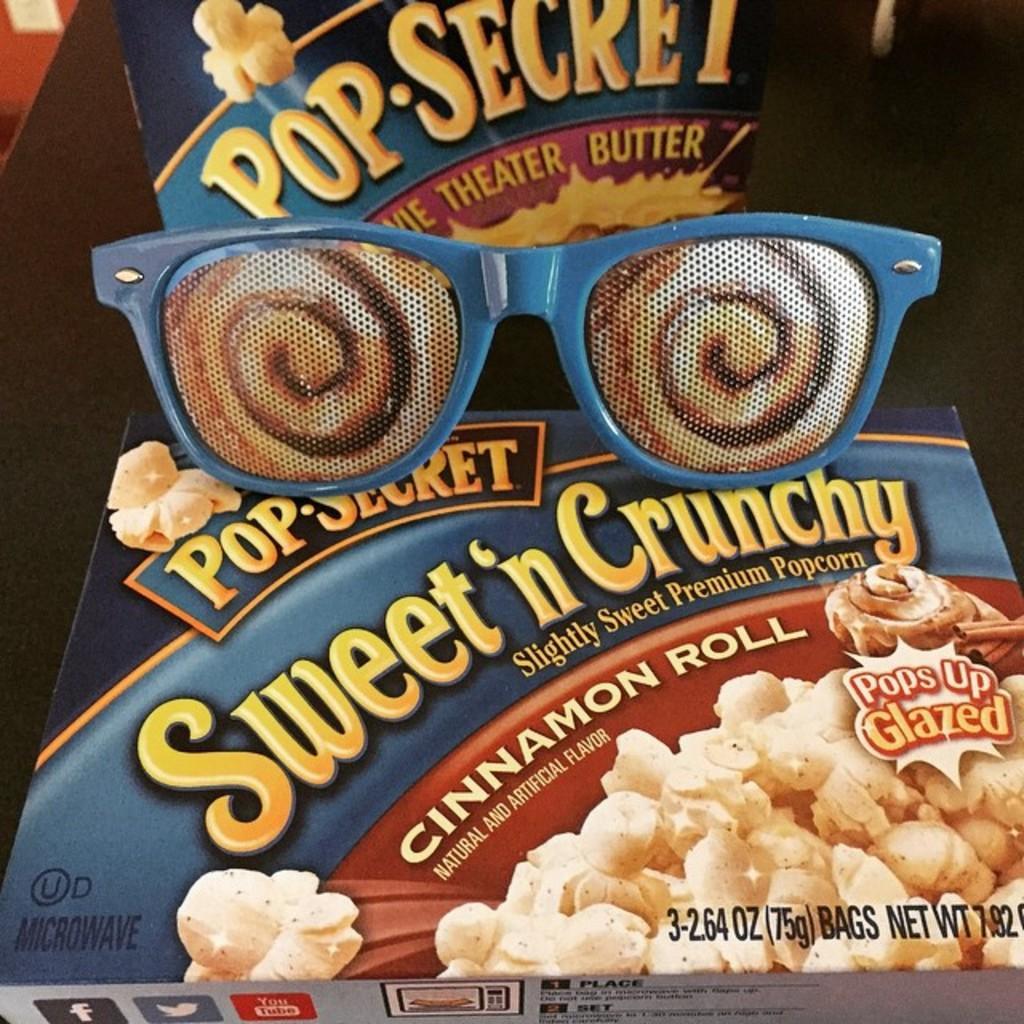Describe this image in one or two sentences. In this image there are snack item box and a goggles are kept on a table as we can see in the middle of this image. 